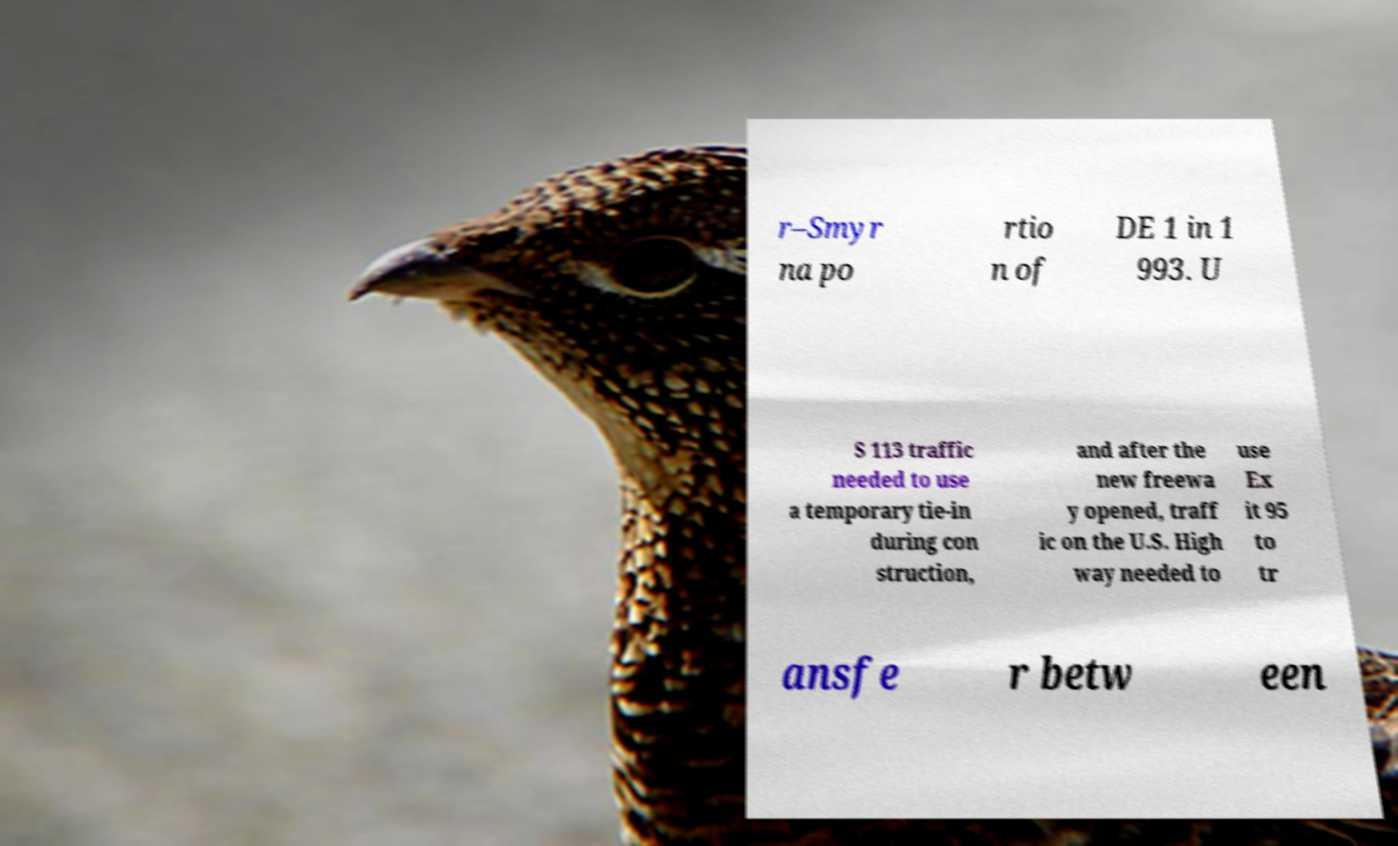I need the written content from this picture converted into text. Can you do that? r–Smyr na po rtio n of DE 1 in 1 993. U S 113 traffic needed to use a temporary tie-in during con struction, and after the new freewa y opened, traff ic on the U.S. High way needed to use Ex it 95 to tr ansfe r betw een 